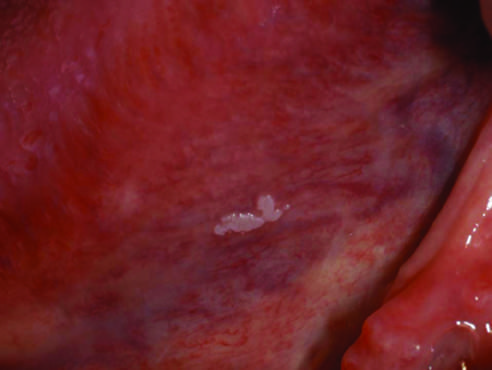s the green probe smooth with well-demarcated borders and minimal elevation in this example?
Answer the question using a single word or phrase. No 